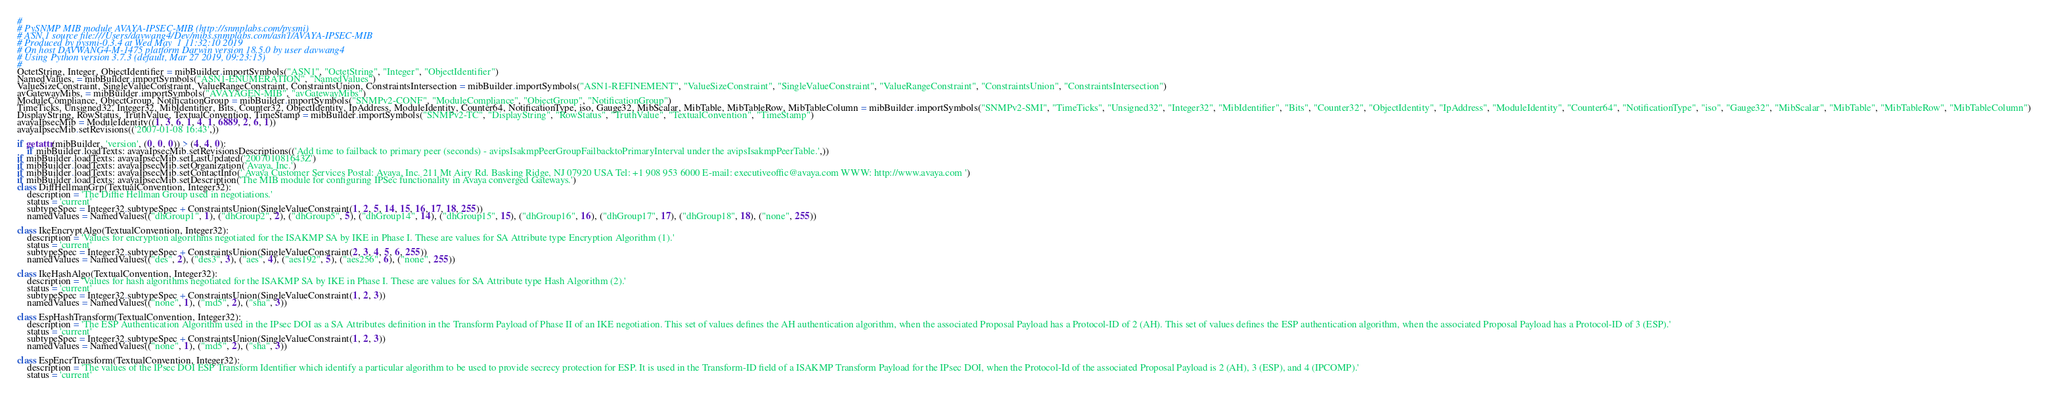Convert code to text. <code><loc_0><loc_0><loc_500><loc_500><_Python_>#
# PySNMP MIB module AVAYA-IPSEC-MIB (http://snmplabs.com/pysmi)
# ASN.1 source file:///Users/davwang4/Dev/mibs.snmplabs.com/asn1/AVAYA-IPSEC-MIB
# Produced by pysmi-0.3.4 at Wed May  1 11:32:10 2019
# On host DAVWANG4-M-1475 platform Darwin version 18.5.0 by user davwang4
# Using Python version 3.7.3 (default, Mar 27 2019, 09:23:15) 
#
OctetString, Integer, ObjectIdentifier = mibBuilder.importSymbols("ASN1", "OctetString", "Integer", "ObjectIdentifier")
NamedValues, = mibBuilder.importSymbols("ASN1-ENUMERATION", "NamedValues")
ValueSizeConstraint, SingleValueConstraint, ValueRangeConstraint, ConstraintsUnion, ConstraintsIntersection = mibBuilder.importSymbols("ASN1-REFINEMENT", "ValueSizeConstraint", "SingleValueConstraint", "ValueRangeConstraint", "ConstraintsUnion", "ConstraintsIntersection")
avGatewayMibs, = mibBuilder.importSymbols("AVAYAGEN-MIB", "avGatewayMibs")
ModuleCompliance, ObjectGroup, NotificationGroup = mibBuilder.importSymbols("SNMPv2-CONF", "ModuleCompliance", "ObjectGroup", "NotificationGroup")
TimeTicks, Unsigned32, Integer32, MibIdentifier, Bits, Counter32, ObjectIdentity, IpAddress, ModuleIdentity, Counter64, NotificationType, iso, Gauge32, MibScalar, MibTable, MibTableRow, MibTableColumn = mibBuilder.importSymbols("SNMPv2-SMI", "TimeTicks", "Unsigned32", "Integer32", "MibIdentifier", "Bits", "Counter32", "ObjectIdentity", "IpAddress", "ModuleIdentity", "Counter64", "NotificationType", "iso", "Gauge32", "MibScalar", "MibTable", "MibTableRow", "MibTableColumn")
DisplayString, RowStatus, TruthValue, TextualConvention, TimeStamp = mibBuilder.importSymbols("SNMPv2-TC", "DisplayString", "RowStatus", "TruthValue", "TextualConvention", "TimeStamp")
avayaIpsecMib = ModuleIdentity((1, 3, 6, 1, 4, 1, 6889, 2, 6, 1))
avayaIpsecMib.setRevisions(('2007-01-08 16:43',))

if getattr(mibBuilder, 'version', (0, 0, 0)) > (4, 4, 0):
    if mibBuilder.loadTexts: avayaIpsecMib.setRevisionsDescriptions(('Add time to failback to primary peer (seconds) - avipsIsakmpPeerGroupFailbacktoPrimaryInterval under the avipsIsakmpPeerTable.',))
if mibBuilder.loadTexts: avayaIpsecMib.setLastUpdated('200701081643Z')
if mibBuilder.loadTexts: avayaIpsecMib.setOrganization('Avaya, Inc.')
if mibBuilder.loadTexts: avayaIpsecMib.setContactInfo(' Avaya Customer Services Postal: Avaya, Inc. 211 Mt Airy Rd. Basking Ridge, NJ 07920 USA Tel: +1 908 953 6000 E-mail: executiveoffic@avaya.com WWW: http://www.avaya.com ')
if mibBuilder.loadTexts: avayaIpsecMib.setDescription('The MIB module for configuring IPSec functionality in Avaya converged Gateways.')
class DiffHellmanGrp(TextualConvention, Integer32):
    description = 'The Diffie Hellman Group used in negotiations.'
    status = 'current'
    subtypeSpec = Integer32.subtypeSpec + ConstraintsUnion(SingleValueConstraint(1, 2, 5, 14, 15, 16, 17, 18, 255))
    namedValues = NamedValues(("dhGroup1", 1), ("dhGroup2", 2), ("dhGroup5", 5), ("dhGroup14", 14), ("dhGroup15", 15), ("dhGroup16", 16), ("dhGroup17", 17), ("dhGroup18", 18), ("none", 255))

class IkeEncryptAlgo(TextualConvention, Integer32):
    description = 'Values for encryption algorithms negotiated for the ISAKMP SA by IKE in Phase I. These are values for SA Attribute type Encryption Algorithm (1).'
    status = 'current'
    subtypeSpec = Integer32.subtypeSpec + ConstraintsUnion(SingleValueConstraint(2, 3, 4, 5, 6, 255))
    namedValues = NamedValues(("des", 2), ("des3", 3), ("aes", 4), ("aes192", 5), ("aes256", 6), ("none", 255))

class IkeHashAlgo(TextualConvention, Integer32):
    description = 'Values for hash algorithms negotiated for the ISAKMP SA by IKE in Phase I. These are values for SA Attribute type Hash Algorithm (2).'
    status = 'current'
    subtypeSpec = Integer32.subtypeSpec + ConstraintsUnion(SingleValueConstraint(1, 2, 3))
    namedValues = NamedValues(("none", 1), ("md5", 2), ("sha", 3))

class EspHashTransform(TextualConvention, Integer32):
    description = 'The ESP Authentication Algorithm used in the IPsec DOI as a SA Attributes definition in the Transform Payload of Phase II of an IKE negotiation. This set of values defines the AH authentication algorithm, when the associated Proposal Payload has a Protocol-ID of 2 (AH). This set of values defines the ESP authentication algorithm, when the associated Proposal Payload has a Protocol-ID of 3 (ESP).'
    status = 'current'
    subtypeSpec = Integer32.subtypeSpec + ConstraintsUnion(SingleValueConstraint(1, 2, 3))
    namedValues = NamedValues(("none", 1), ("md5", 2), ("sha", 3))

class EspEncrTransform(TextualConvention, Integer32):
    description = 'The values of the IPsec DOI ESP Transform Identifier which identify a particular algorithm to be used to provide secrecy protection for ESP. It is used in the Transform-ID field of a ISAKMP Transform Payload for the IPsec DOI, when the Protocol-Id of the associated Proposal Payload is 2 (AH), 3 (ESP), and 4 (IPCOMP).'
    status = 'current'</code> 